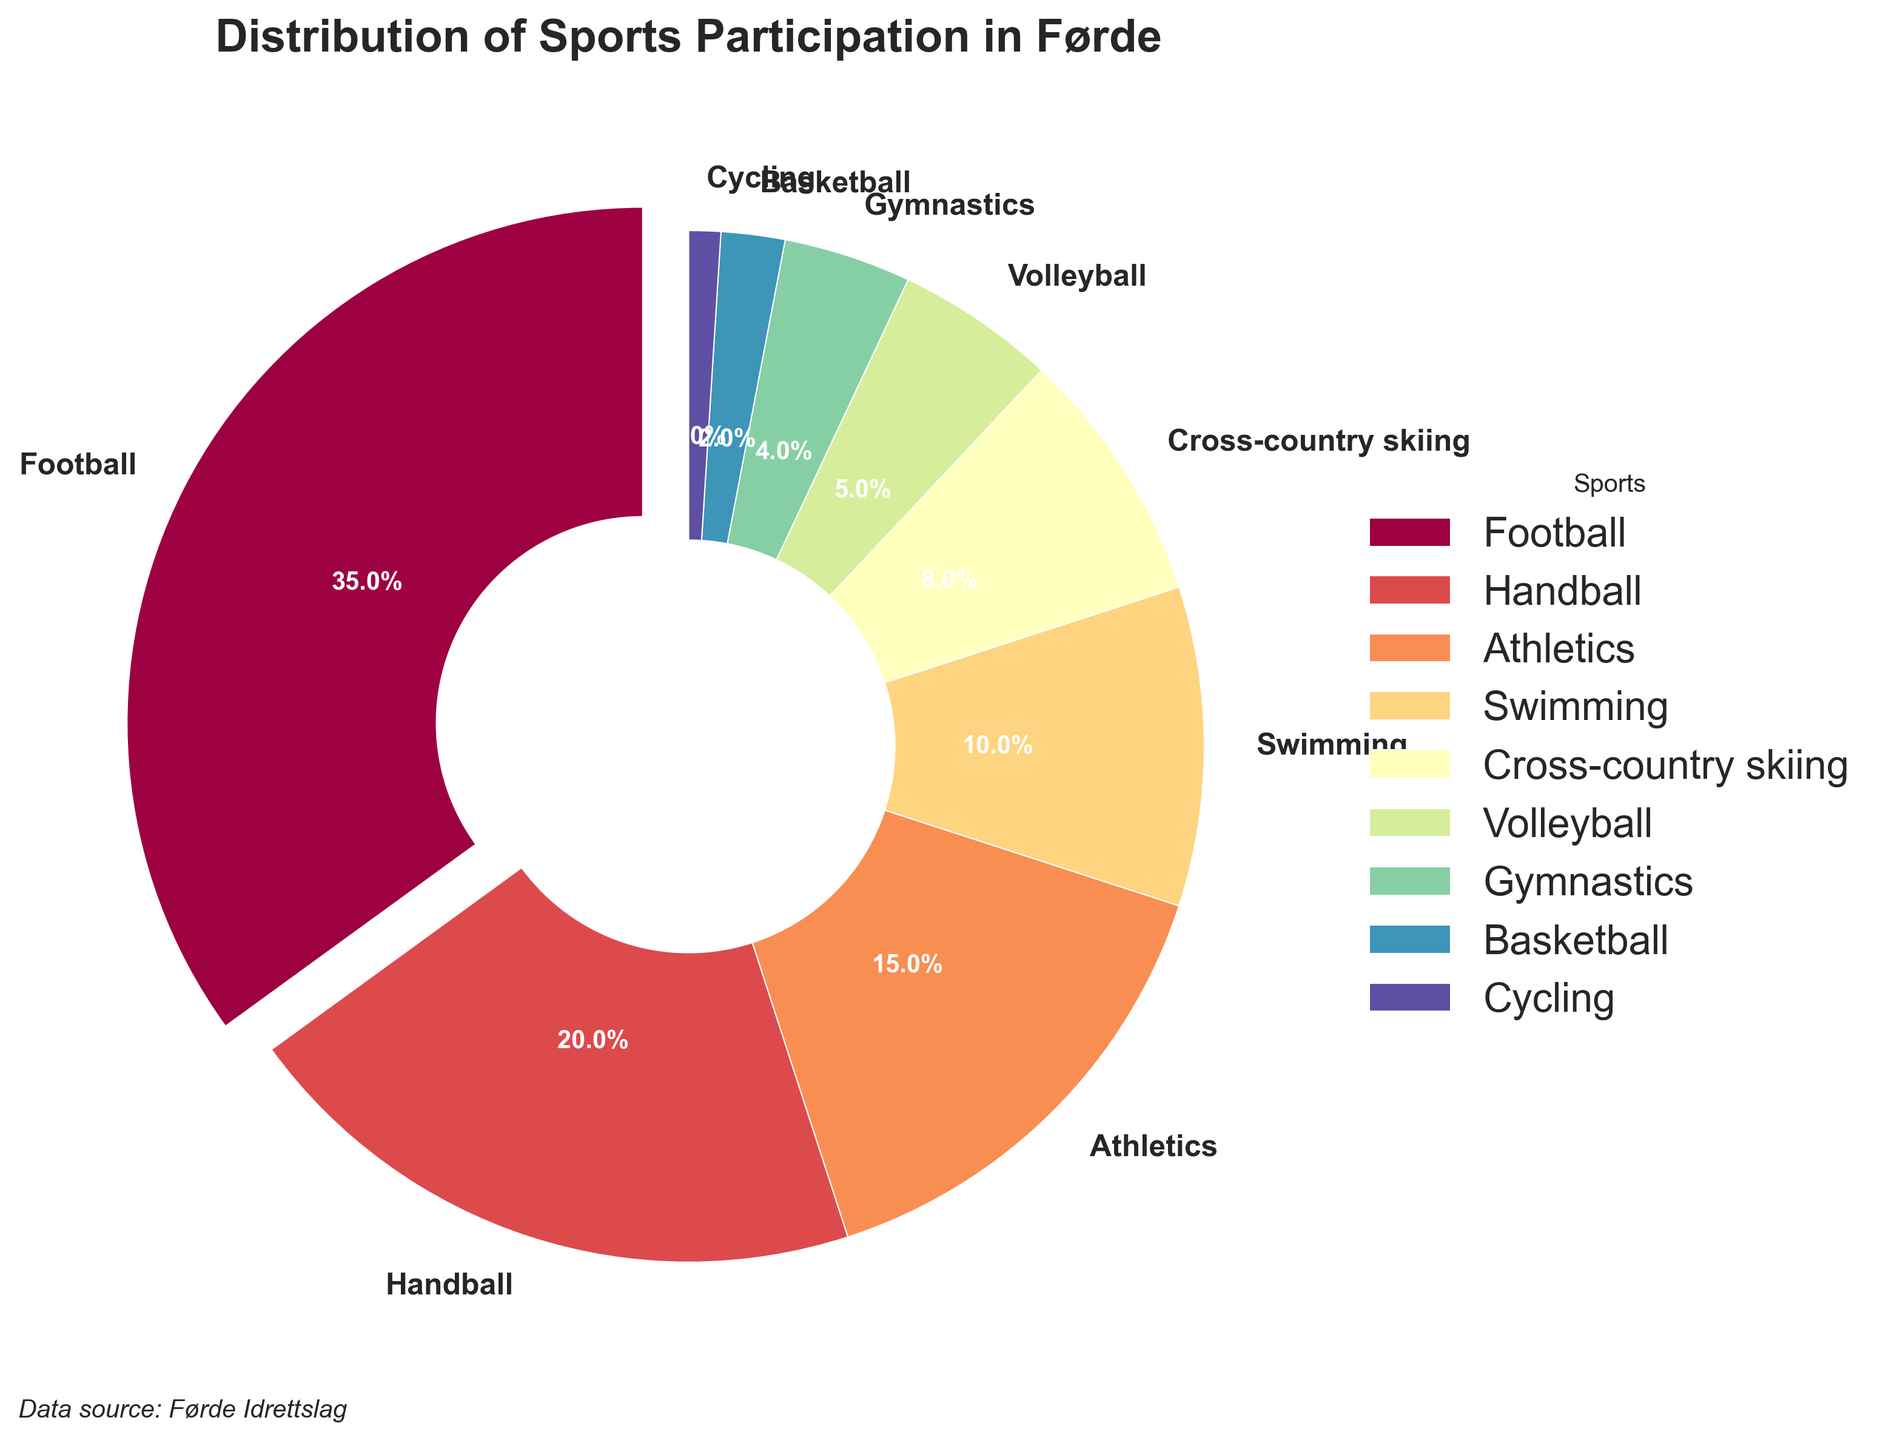What is the most popular sport in Førde in terms of participation percentage? The figure shows various sports with their participation percentages. The largest wedge is often a good indicator of the most popular sport. In this case, Football has the largest wedge, and it's labeled as 35%.
Answer: Football What is the total percentage of participants in Handball and Volleyball combined? Add the participation percentages of Handball (20%) and Volleyball (5%). Thus, the sum is 20% + 5% = 25%.
Answer: 25% Which sport has the lowest participation rate? Identify the smallest wedge on the pie chart. The smallest wedge represents Cycling with a percentage of 1%.
Answer: Cycling How much more popular is Football compared to Athletics? Subtract the percentage for Athletics (15%) from the percentage for Football (35%). The difference is 35% - 15% = 20%.
Answer: 20% What percentage of participants are in sports other than Football? Subtract Football's percentage (35%) from 100% to get the percentage of participants in other sports. The calculation is 100% - 35% = 65%.
Answer: 65% Compare the participation in Swimming to Gymnastics. Which is more popular and by how much? Identify the percentages for each sport: Swimming (10%) and Gymnastics (4%). Subtract Gymnastics from Swimming: 10% - 4% = 6%. Swimming is more popular by 6%.
Answer: Swimming, 6% What is the cumulative percentage of participants in Aquatic sports (Swimming) and Athletics? Sum the percentages for Swimming (10%) and Athletics (15%). The total is 10% + 15% = 25%.
Answer: 25% What is the percentage difference between Cross-country skiing and Handball? Subtract the percentage for Cross-country skiing (8%) from Handball (20%). The difference is 20% - 8% = 12%.
Answer: 12% Which sport's wedge is represented by a dark blue color in the pie chart? Observing the color spectrum used in the pie chart, the dark blue wedge corresponds to the sport listed next to it. In this case, Cross-country skiing is shown in dark blue.
Answer: Cross-country skiing 